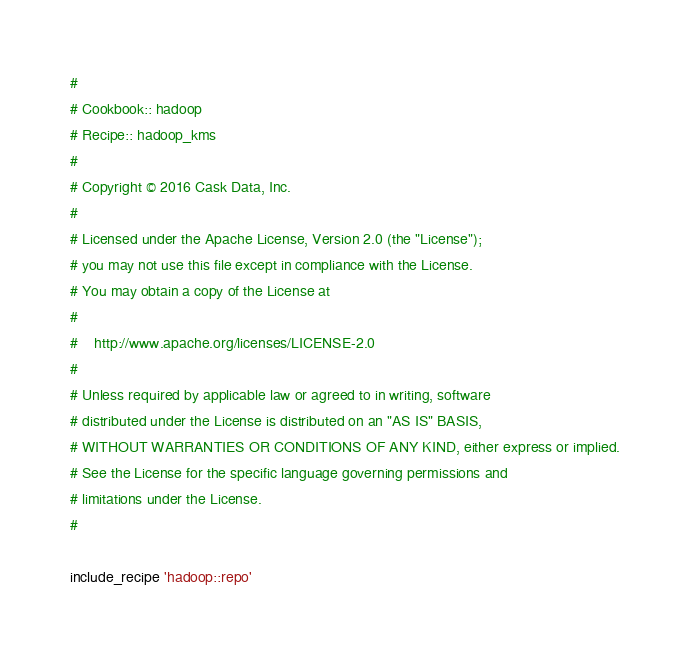Convert code to text. <code><loc_0><loc_0><loc_500><loc_500><_Ruby_>#
# Cookbook:: hadoop
# Recipe:: hadoop_kms
#
# Copyright © 2016 Cask Data, Inc.
#
# Licensed under the Apache License, Version 2.0 (the "License");
# you may not use this file except in compliance with the License.
# You may obtain a copy of the License at
#
#    http://www.apache.org/licenses/LICENSE-2.0
#
# Unless required by applicable law or agreed to in writing, software
# distributed under the License is distributed on an "AS IS" BASIS,
# WITHOUT WARRANTIES OR CONDITIONS OF ANY KIND, either express or implied.
# See the License for the specific language governing permissions and
# limitations under the License.
#

include_recipe 'hadoop::repo'
</code> 